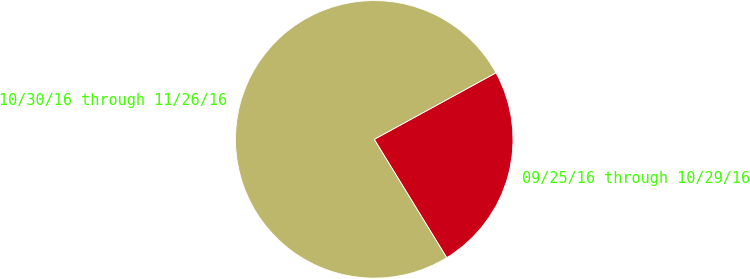Convert chart to OTSL. <chart><loc_0><loc_0><loc_500><loc_500><pie_chart><fcel>09/25/16 through 10/29/16<fcel>10/30/16 through 11/26/16<nl><fcel>24.22%<fcel>75.78%<nl></chart> 